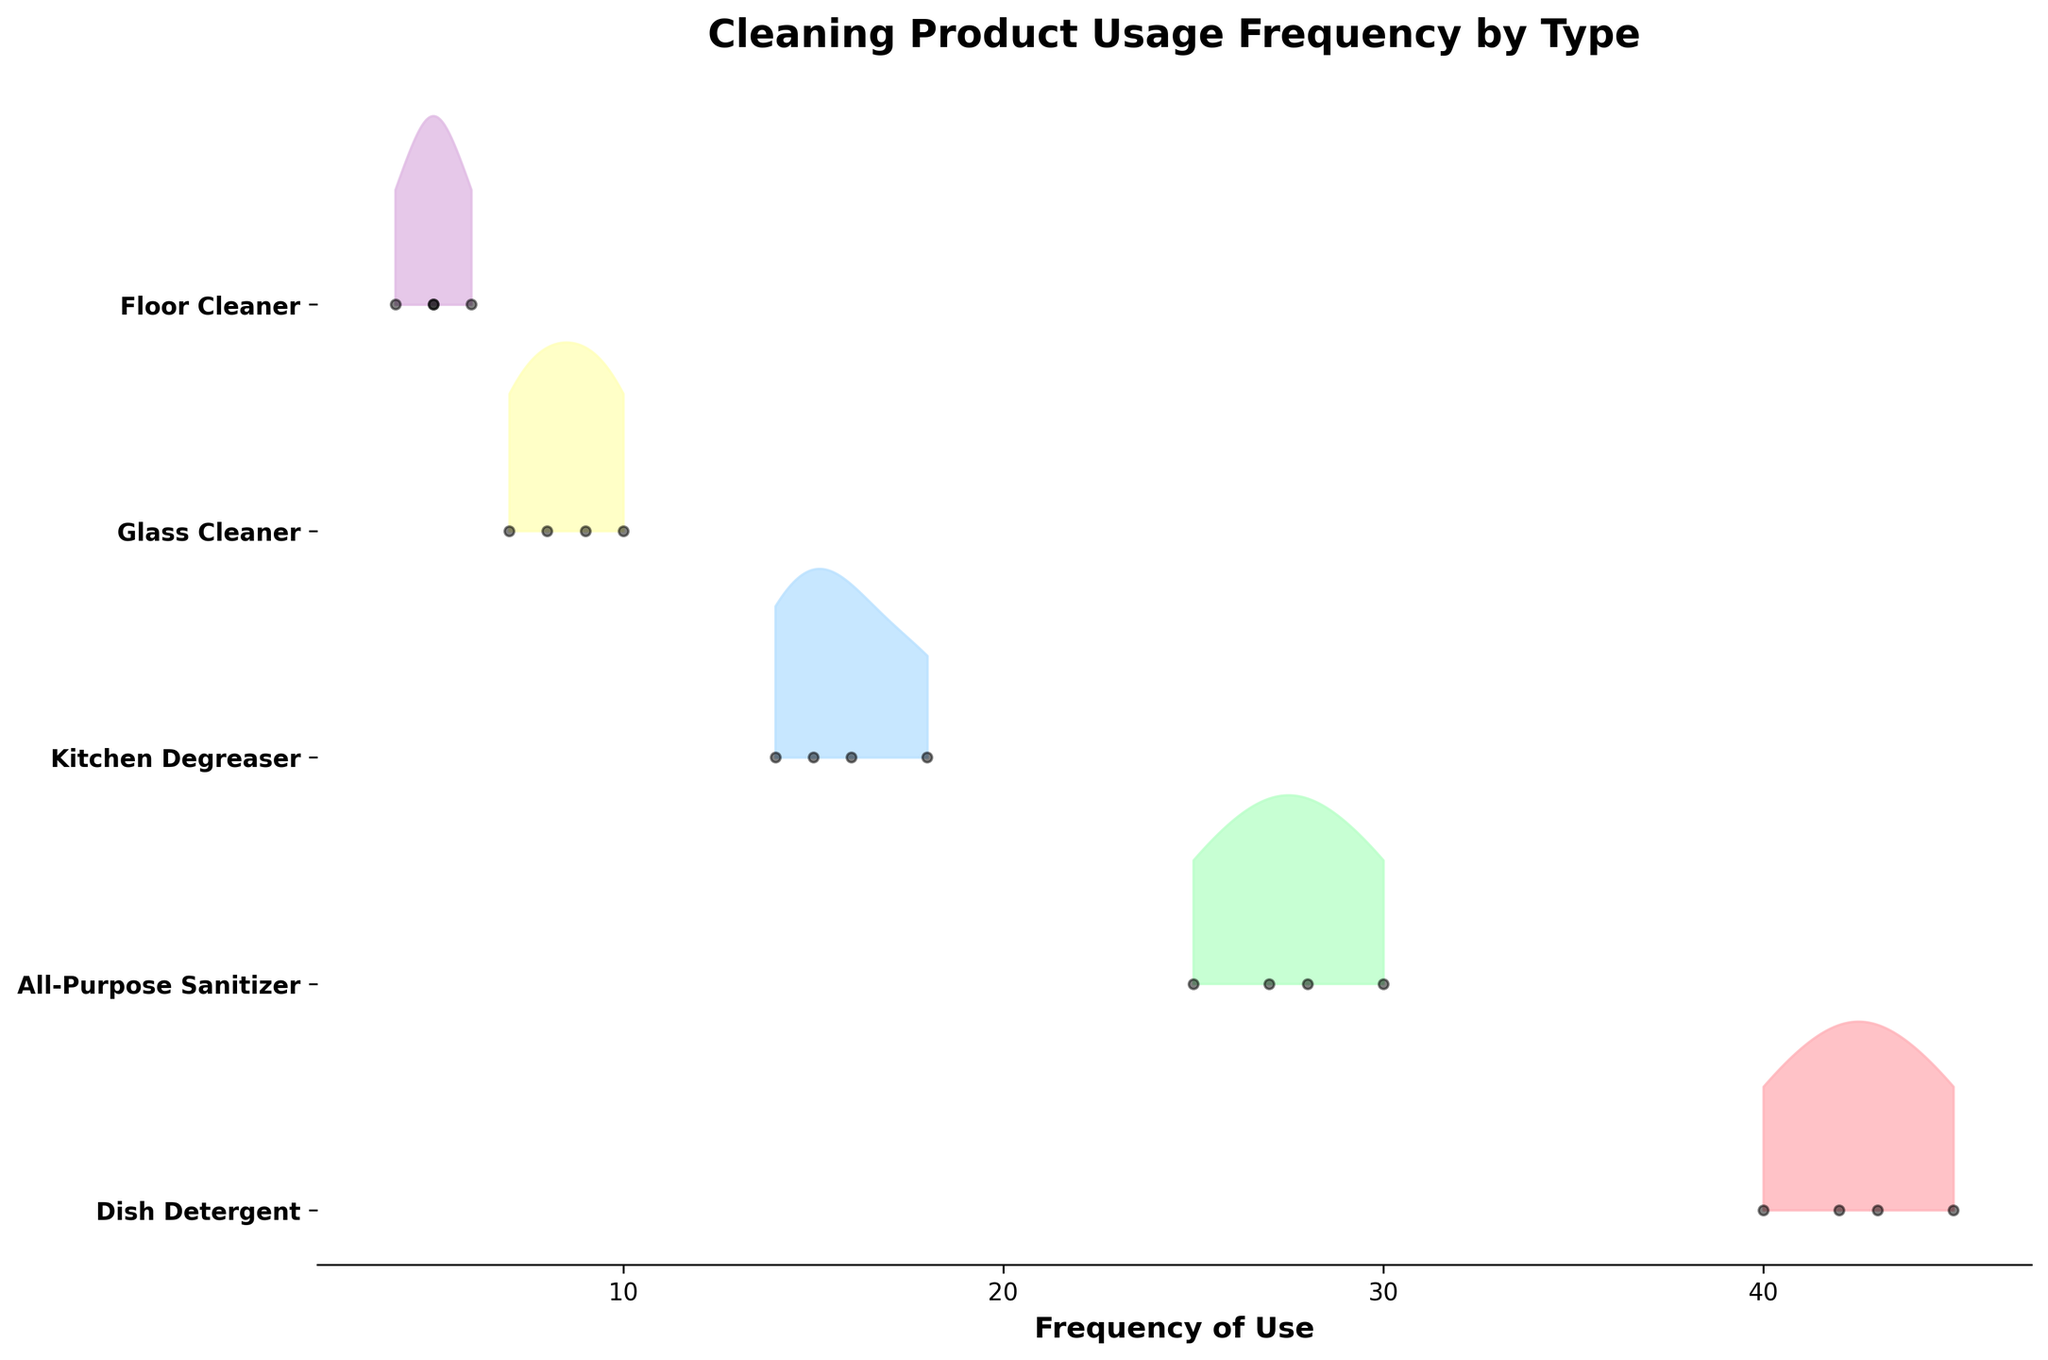What is the title of the plot? The title of the plot is usually located at the top and provides a description of what the plot is about.
Answer: Cleaning Product Usage Frequency by Type Which cleaning product has the highest frequency of use? By looking at the ridgeline plot, the cleaning product with the highest KDE peak and frequency dots indicates the most usage.
Answer: Dish Detergent Which cleaning product has the lowest frequency of use? By referring to the plot, the product with the lowest KDE peak and frequency dots indicates the least usage.
Answer: Floor Cleaner What's the frequency range for the All-Purpose Sanitizer across the month? Check the extent of data points for the All-Purpose Sanitizer along the x-axis which represents the frequency of use.
Answer: 25 to 30 How does the usage of Kitchen Degreaser in Week 1 compare to Week 4? Compare the frequency points on the plot for Week 1 and Week 4 for the Kitchen Degreaser.
Answer: Week 1: 15, Week 4: 16 Which product shows the most consistent usage over the four weeks? Consistent usage can be inferred where the data points for that product are clustered closely together, with minimal fluctuation in frequencies.
Answer: Dish Detergent On average, did the usage of Glass Cleaner increase or decrease over the month? Calculate the average frequency for each week and compare Week 1 with Week 4 to identify the trend.
Answer: Increased What's the average frequency of usage for Floor Cleaner? Sum the frequency values for all four weeks and divide by the number of weeks to get the average. Automation might help, but visually estimation is needed.
Answer: 5+6+4+5 = 20; 20/4 = 5 Which week had the highest overall frequency of cleaning product usage? Sum the frequencies for each week across all products and identify the week with the highest total.
Answer: Week 2 Is there a product whose frequency of usage decreased every week? Check the trend lines for each product to see if any have a consistently decreasing pattern from Week 1 to Week 4.
Answer: No 